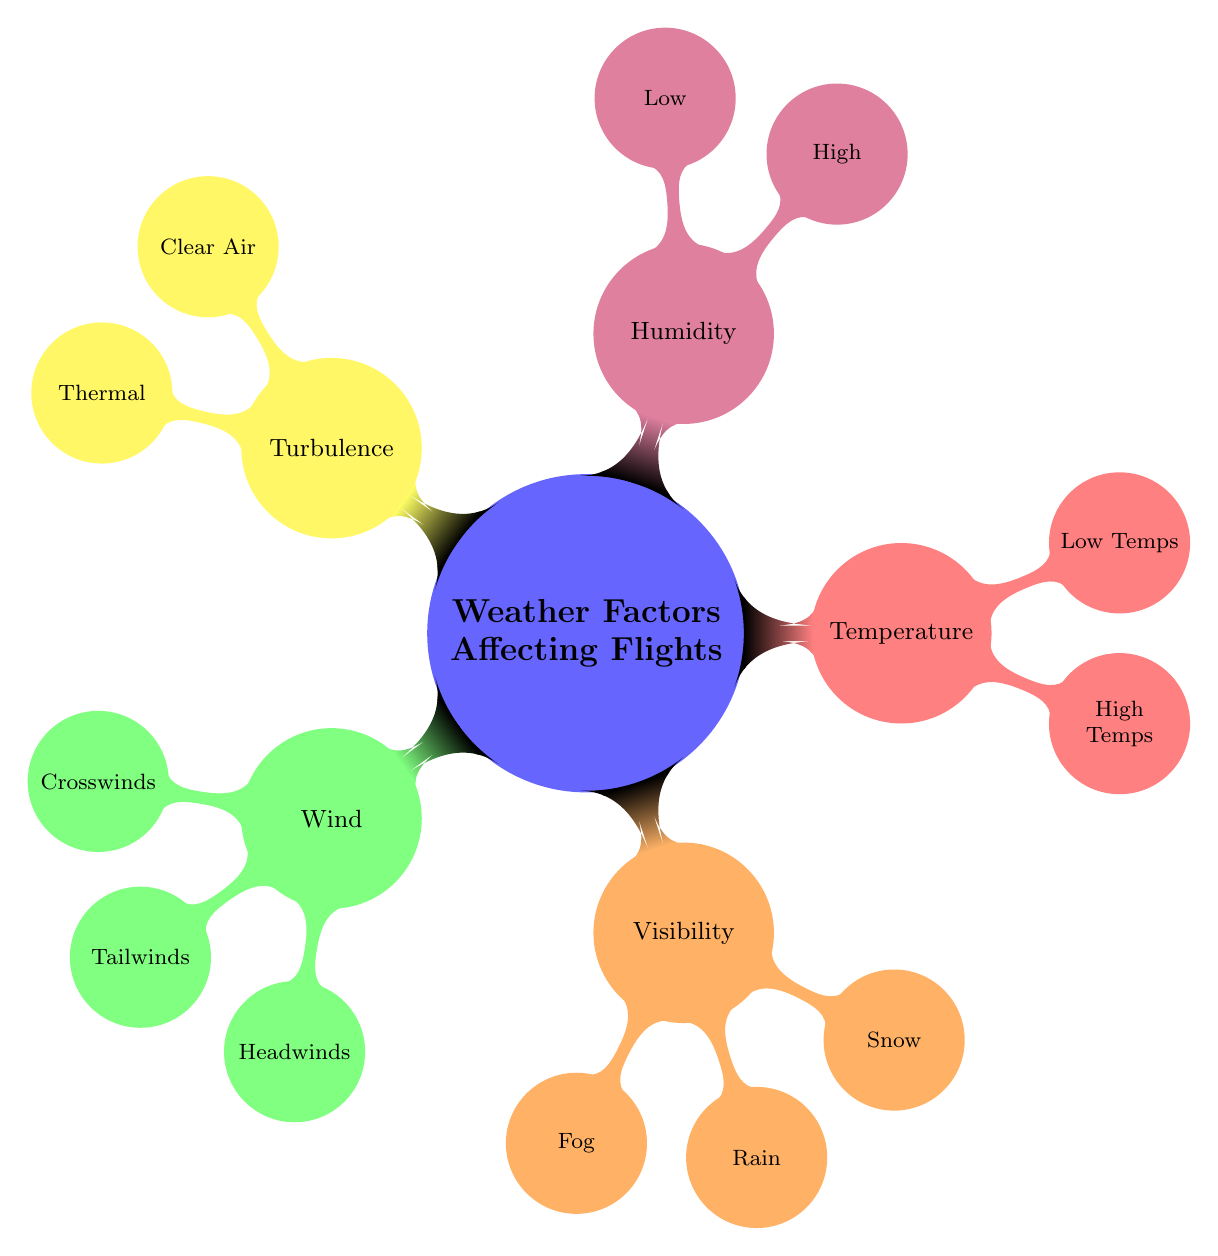What are the main categories of weather factors affecting flights? The diagram identifies five main categories: Wind, Visibility, Temperature, Humidity, and Turbulence. Each of these represents a different aspect of weather that can impact flying conditions.
Answer: Wind, Visibility, Temperature, Humidity, Turbulence How many child nodes are under the Visibility category? The Visibility category has three child nodes listed: Fog, Rain, and Snow. This shows that there are three specific weather conditions that affect visibility.
Answer: 3 What type of turbulence is difficult to predict? Clear Air Turbulence is mentioned as being tough to predict, indicating that this type of turbulence can occur in clear skies without obvious signs.
Answer: Clear Air What are the two possible effects of High Temperatures on aircraft? High Temperatures can affect aircraft performance and engine efficiency, which shows that extreme heat can hinder the operation of the aircraft.
Answer: Performance, engine efficiency Which humidity level is generally better for flight performance? Low Humidity is indicated as better for flight performance, suggesting that moisture in the air can negatively impact flying conditions.
Answer: Low What weather condition can cause a risk of icing on wings? Low Temperatures can lead to icing, posing a significant risk to the aircraft's wings and control surfaces during flight.
Answer: Low Temperatures In which category would you find Tailwinds? Tailwinds are located under the Wind category, indicating that this specific wind condition affects speed during flight.
Answer: Wind How many types of visibility-reducing weather conditions are listed? There are three types of visibility-reducing weather conditions: Fog, Rain, and Snow. This highlights the various weather phenomena that can impair pilot visibility.
Answer: 3 